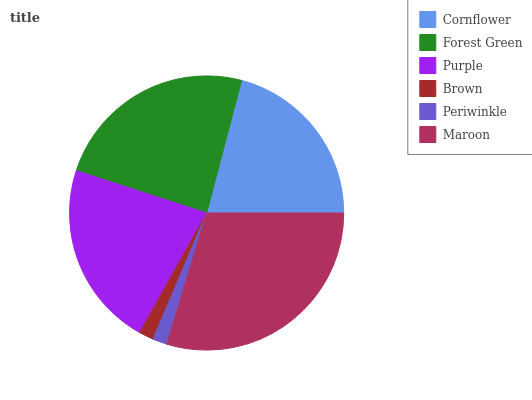Is Periwinkle the minimum?
Answer yes or no. Yes. Is Maroon the maximum?
Answer yes or no. Yes. Is Forest Green the minimum?
Answer yes or no. No. Is Forest Green the maximum?
Answer yes or no. No. Is Forest Green greater than Cornflower?
Answer yes or no. Yes. Is Cornflower less than Forest Green?
Answer yes or no. Yes. Is Cornflower greater than Forest Green?
Answer yes or no. No. Is Forest Green less than Cornflower?
Answer yes or no. No. Is Purple the high median?
Answer yes or no. Yes. Is Cornflower the low median?
Answer yes or no. Yes. Is Cornflower the high median?
Answer yes or no. No. Is Periwinkle the low median?
Answer yes or no. No. 